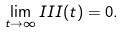Convert formula to latex. <formula><loc_0><loc_0><loc_500><loc_500>\lim _ { t \to \infty } I I I ( t ) = 0 .</formula> 